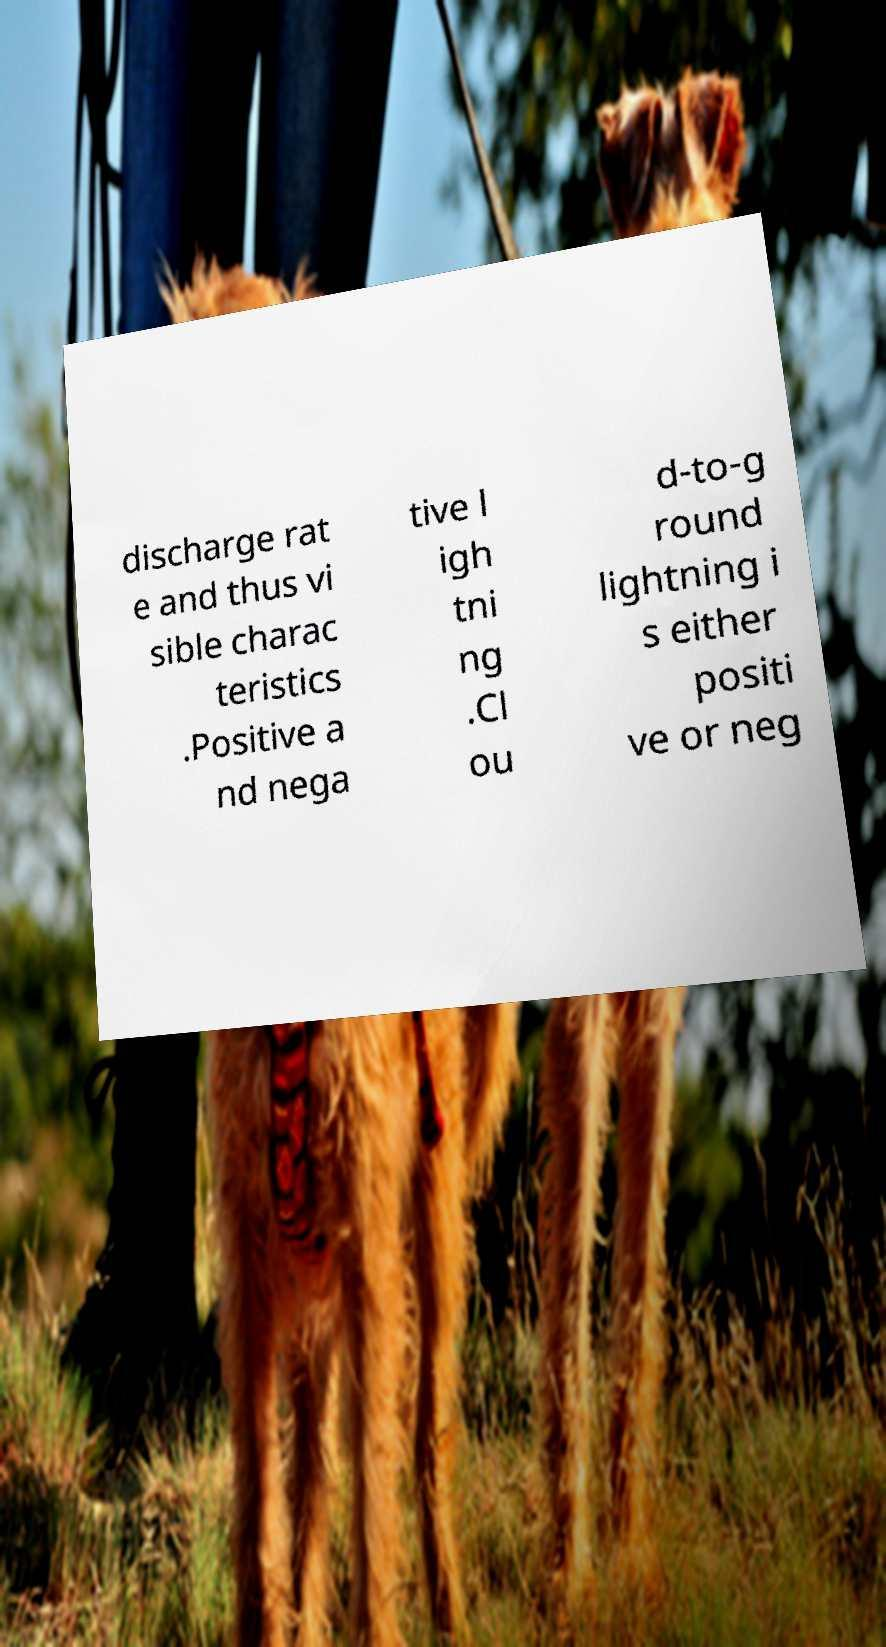What messages or text are displayed in this image? I need them in a readable, typed format. discharge rat e and thus vi sible charac teristics .Positive a nd nega tive l igh tni ng .Cl ou d-to-g round lightning i s either positi ve or neg 